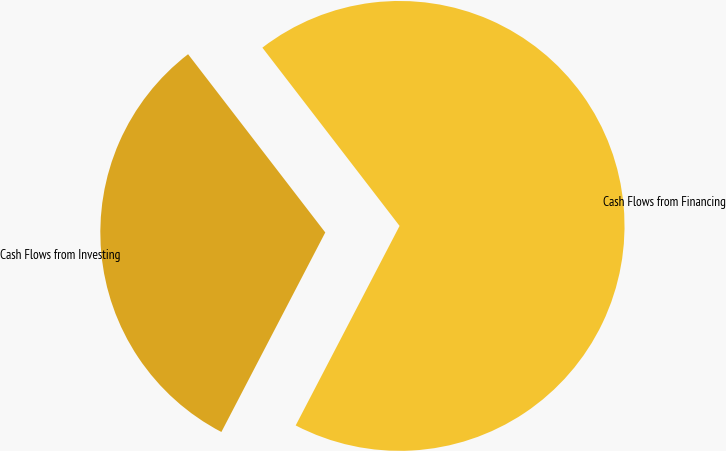Convert chart. <chart><loc_0><loc_0><loc_500><loc_500><pie_chart><fcel>Cash Flows from Investing<fcel>Cash Flows from Financing<nl><fcel>31.92%<fcel>68.08%<nl></chart> 